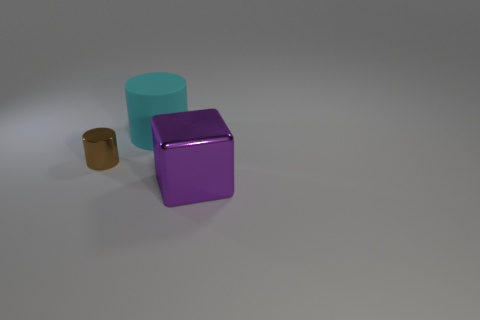Subtract all brown cylinders. Subtract all green spheres. How many cylinders are left? 1 Add 1 red blocks. How many objects exist? 4 Subtract all cylinders. How many objects are left? 1 Add 2 rubber things. How many rubber things exist? 3 Subtract 0 yellow cylinders. How many objects are left? 3 Subtract all big yellow balls. Subtract all big cyan cylinders. How many objects are left? 2 Add 3 brown metal things. How many brown metal things are left? 4 